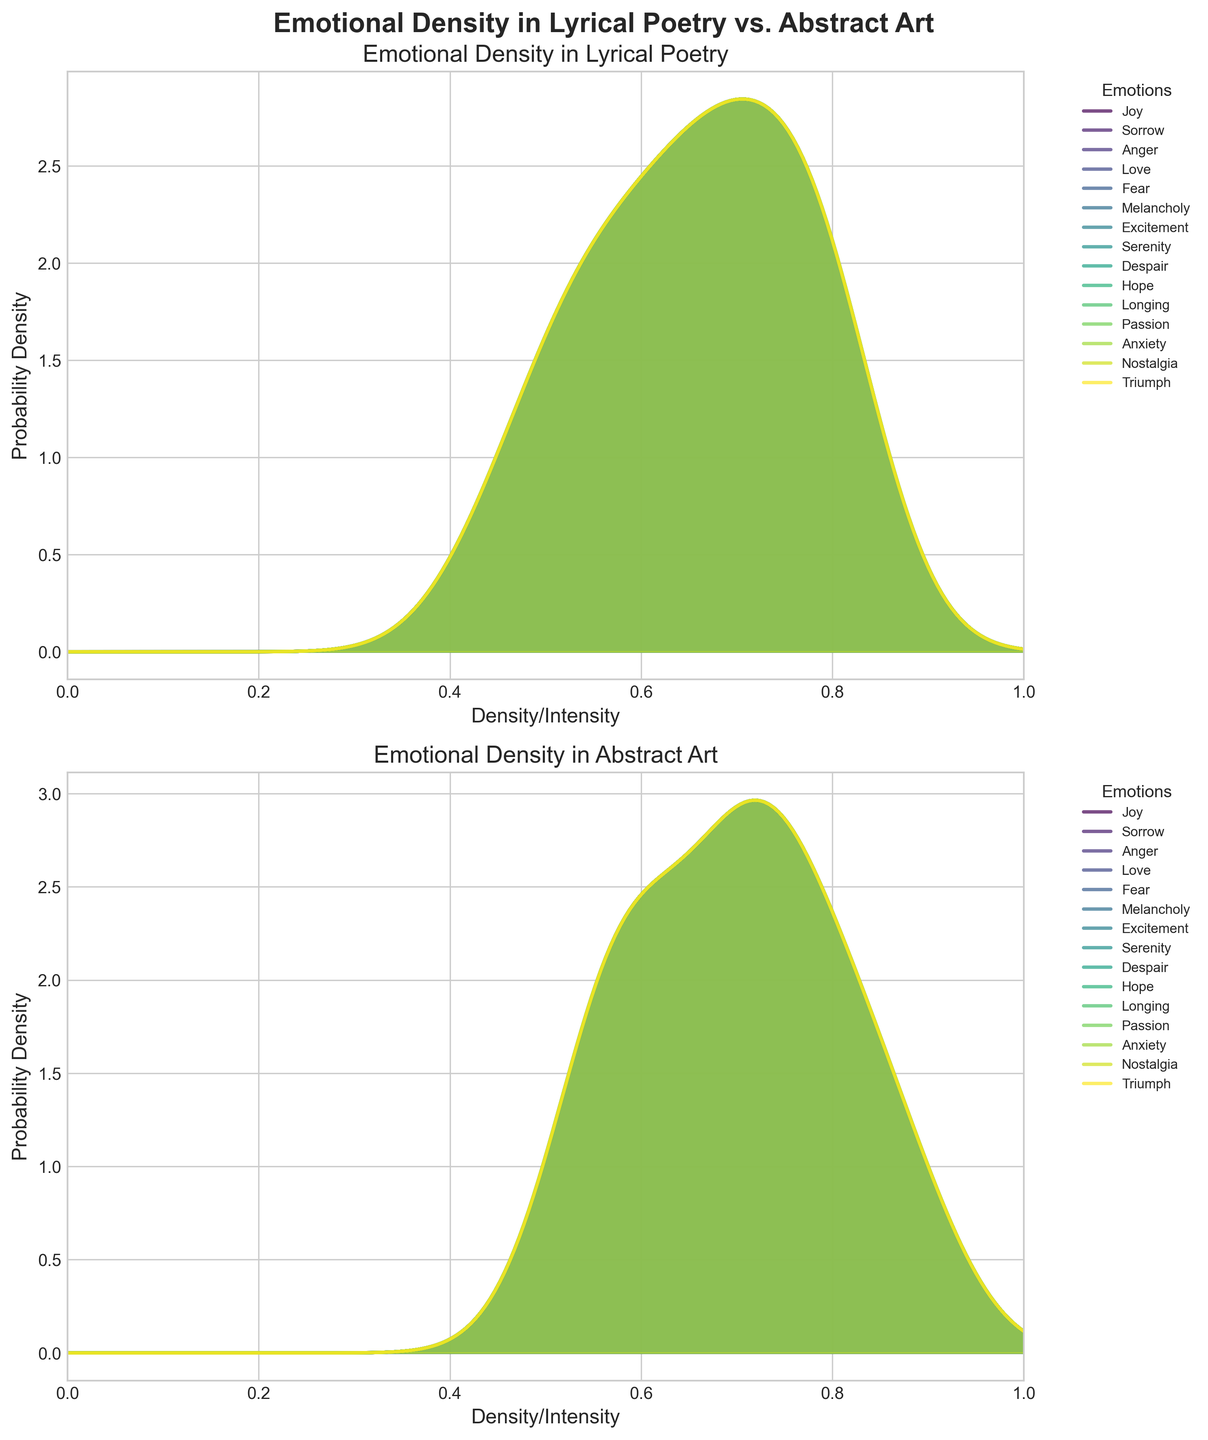What's the title of the entire figure? The title is usually found at the top of the figure and acts as a summary of what the figure represents.
Answer: Emotional Density in Lyrical Poetry vs. Abstract Art How many different emotions are represented in the figure? Each color and label on the density plots represent a different emotion. There are 15 emotions listed in the data.
Answer: 15 Which emotion in lyrical poetry appears to have the highest peak density? By observing the density plot for lyrical poetry, the highest peak represents the emotion with the highest density.
Answer: Love What is the range of the X-axis for both subplots? The range of the X-axis can be seen on the horizontal axis of both plots.
Answer: 0 to 1 Which emotions have higher density in lyrical poetry compared to abstract art? To compare the densities, we observe where the density lines for each emotion in lyrical poetry are higher than in abstract art.
Answer: Love, Sorrow, Melancholy, Despair, Longing, Passion What can be inferred if an emotion has similar density peaks in both lyrical poetry and abstract art? Similar density peaks in both plots suggest that the emotional expression through colors in abstract art correlates closely with the use of emotive language in lyrical poetry for that emotion.
Answer: Correlation in expression Are there any emotions consistently higher in abstract art compared to lyrical poetry? By comparing the density peaks in the second plot for abstract art to those in the first plot for lyrical poetry, we can identify which emotions have higher peaks in abstract art.
Answer: Anger, Fear, Excitement, Triumph What is the density/intensity value where Fear peaks in abstract art? Identify where the plot line for Fear reaches its highest point in the abstract art subplot and note the corresponding X-axis value.
Answer: Around 0.76 Which emotions have nearly identical probabilities in both lyrical poetry and abstract art? By comparing the shapes and heights of the density plots, we can see if any emotions show nearly identical patterns in both subplots.
Answer: Joy, Nostalgia Across which range do most emotions in lyrical poetry show peak density? Look at the X-values where most of the emotion curves hit their highest points in the lyrical poetry subplot.
Answer: 0.6 - 0.8 